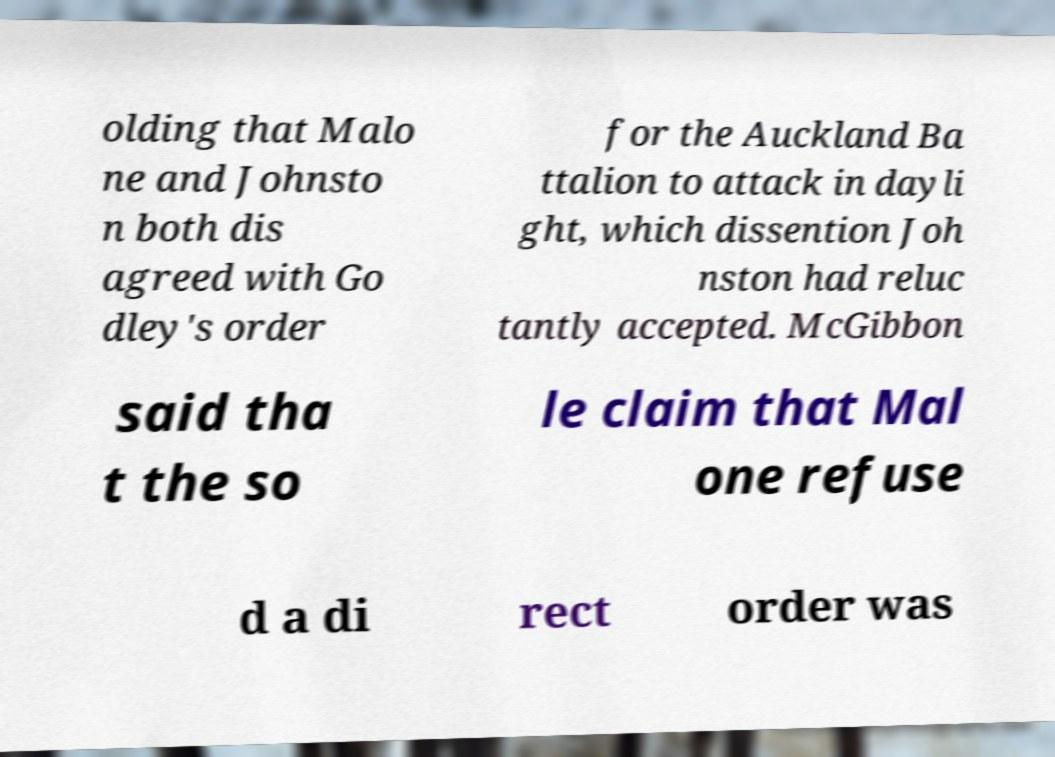Can you read and provide the text displayed in the image?This photo seems to have some interesting text. Can you extract and type it out for me? olding that Malo ne and Johnsto n both dis agreed with Go dley's order for the Auckland Ba ttalion to attack in dayli ght, which dissention Joh nston had reluc tantly accepted. McGibbon said tha t the so le claim that Mal one refuse d a di rect order was 